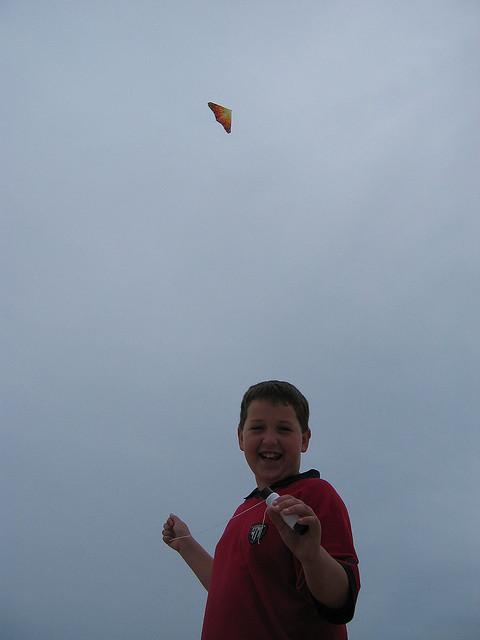Is it sunny?
Write a very short answer. No. What kind of tie is the bear wearing?
Be succinct. None. What kind of hairdo does the guy in the picture have?
Be succinct. Short. What color is the boy's shirt?
Short answer required. Red. How does this animal reproduce?
Quick response, please. Sex. Does the man have facial hair?
Keep it brief. No. What is the boy doing?
Concise answer only. Flying kite. What is he doing?
Short answer required. Flying kite. What shape is the kite?
Quick response, please. Triangle. What color shirt is he wearing?
Write a very short answer. Red. How many strings is used to fly this kite?
Write a very short answer. 1. Are there more than one person flying kites?
Short answer required. No. What is the man doing?
Short answer required. Flying kite. Is the sun setting in the background??
Keep it brief. No. What is the man carrying?
Keep it brief. Kite. How many people are there behind the man in red?
Answer briefly. 0. Sexes of the individuals in the image?
Quick response, please. Male. Is this boy singing into a microphone?
Keep it brief. No. Is there water?
Give a very brief answer. No. Is this person in motion?
Concise answer only. No. How many eyes are there?
Write a very short answer. 2. What color is his shirt?
Concise answer only. Red. What is the person in the background carrying?
Keep it brief. Kite. What is the child holding?
Write a very short answer. Kite. What kind of toy does the child have?
Answer briefly. Kite. How old is the child?
Short answer required. 12. Is the person a male or female?
Give a very brief answer. Male. What is the color of the sky?
Keep it brief. Gray. Can you see water?
Be succinct. No. What is the kite supposed to be?
Be succinct. Bird. Where is the boy's left hand?
Concise answer only. Kite. Does the boy look worried?
Be succinct. No. What gender is the person with the kite?
Concise answer only. Male. 